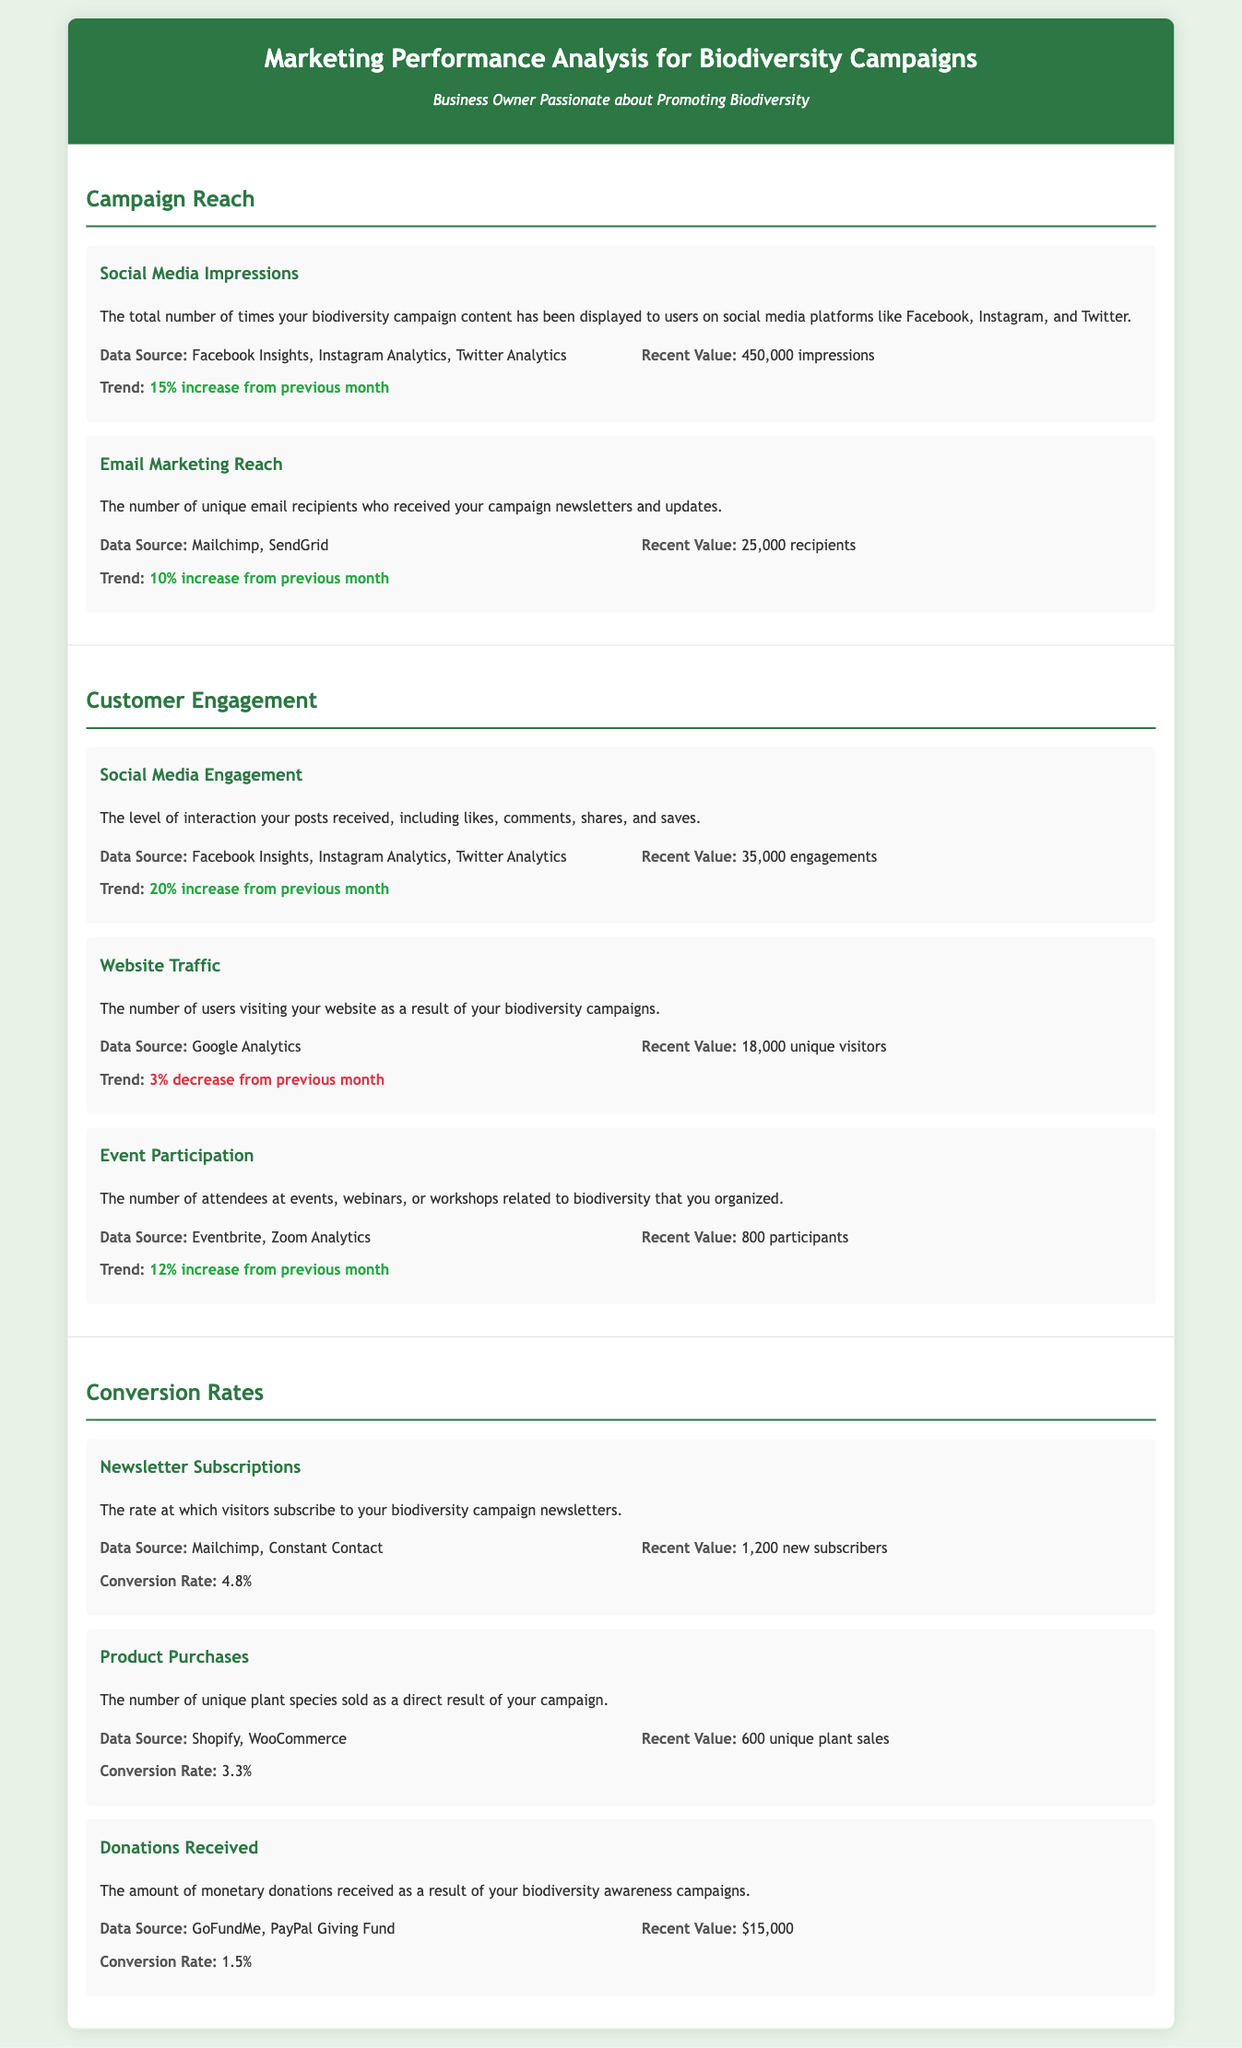What is the total number of social media impressions? The document states that the recent value of social media impressions is 450,000.
Answer: 450,000 What was the trend in email marketing reach? The document indicates that the trend for email marketing reach is a 10% increase from the previous month.
Answer: 10% increase How many unique plant species were sold? The recent value for product purchases shows 600 unique plant sales.
Answer: 600 What is the recent value of newsletter subscriptions? According to the document, the recent value for newsletter subscriptions is 1,200 new subscribers.
Answer: 1,200 What was the level of social media engagement? The document records a recent value of 35,000 engagements in social media.
Answer: 35,000 What is the conversion rate for donations received? The conversion rate for donations received is indicated as 1.5%.
Answer: 1.5% What was the recent value of event participation? The document lists the recent value of event participation as 800 participants.
Answer: 800 What is the trend for website traffic? The document states that there is a 3% decrease in website traffic from the previous month.
Answer: 3% decrease How many unique email recipients received the campaign newsletters? The document notes that 25,000 unique email recipients received the campaign newsletters.
Answer: 25,000 